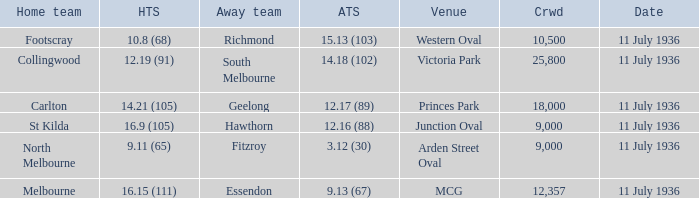When was the game with richmond as Away team? 11 July 1936. 